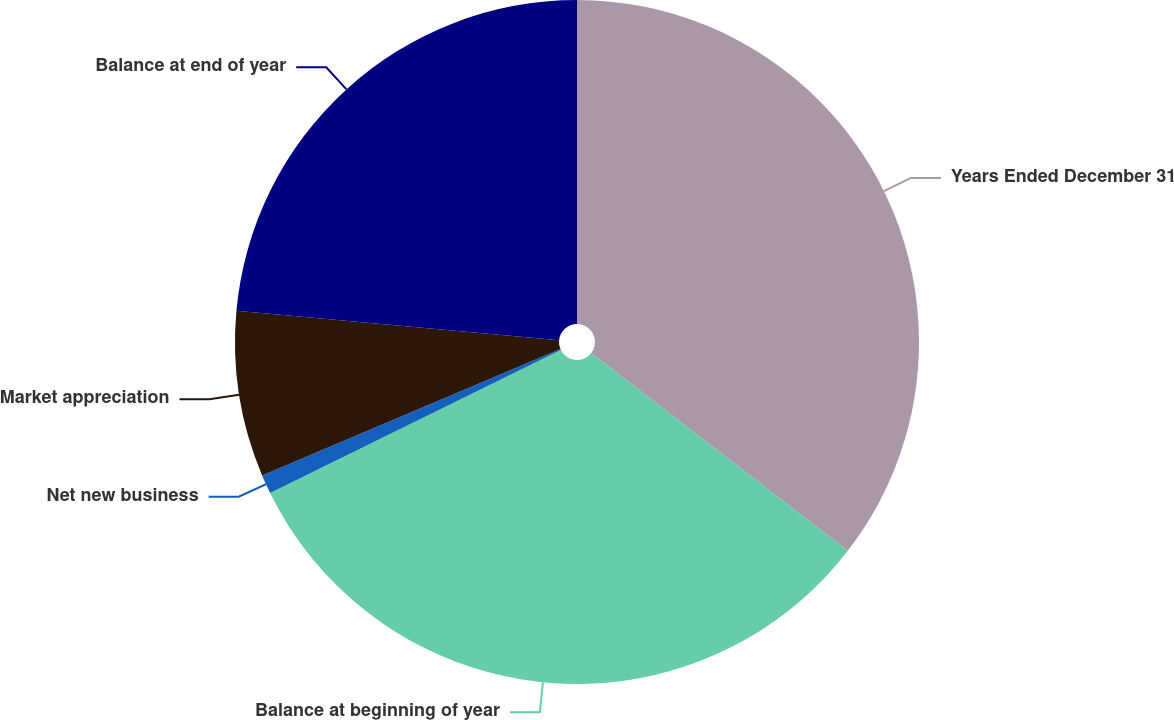Convert chart to OTSL. <chart><loc_0><loc_0><loc_500><loc_500><pie_chart><fcel>Years Ended December 31<fcel>Balance at beginning of year<fcel>Net new business<fcel>Market appreciation<fcel>Balance at end of year<nl><fcel>35.46%<fcel>32.27%<fcel>0.9%<fcel>7.83%<fcel>23.55%<nl></chart> 